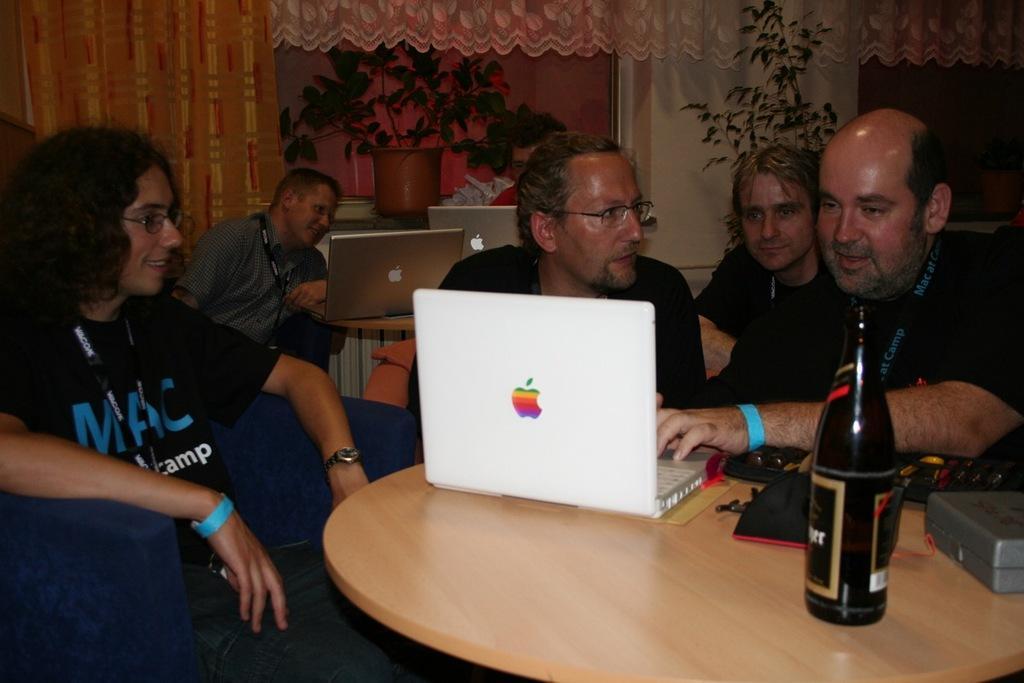Could you give a brief overview of what you see in this image? Bottom right side of the image there is a table on the table there is a bottle, laptop and there is a box. Top right side of the image few people are sitting and looking in to a laptop. Behind them there is a plant and wall. In the middle of the image two persons sitting on a chairs in front of them there is a table on the table there are two laptops. Behind them there is a plant. Bottom left side of the image a person is sitting and smiling. Behind him there is a curtain. 